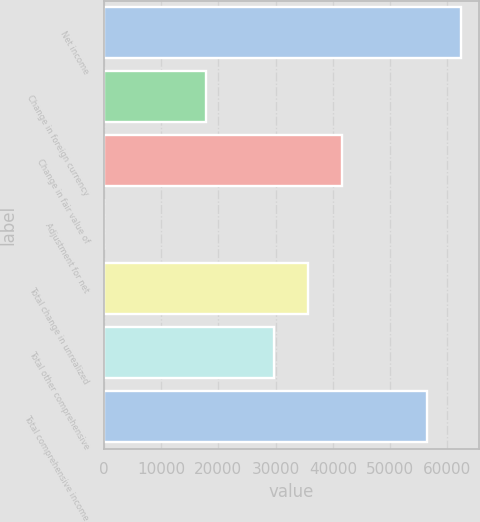<chart> <loc_0><loc_0><loc_500><loc_500><bar_chart><fcel>Net income<fcel>Change in foreign currency<fcel>Change in fair value of<fcel>Adjustment for net<fcel>Total change in unrealized<fcel>Total other comprehensive<fcel>Total comprehensive income<nl><fcel>62458<fcel>17860<fcel>41672<fcel>1<fcel>35719<fcel>29766<fcel>56505<nl></chart> 